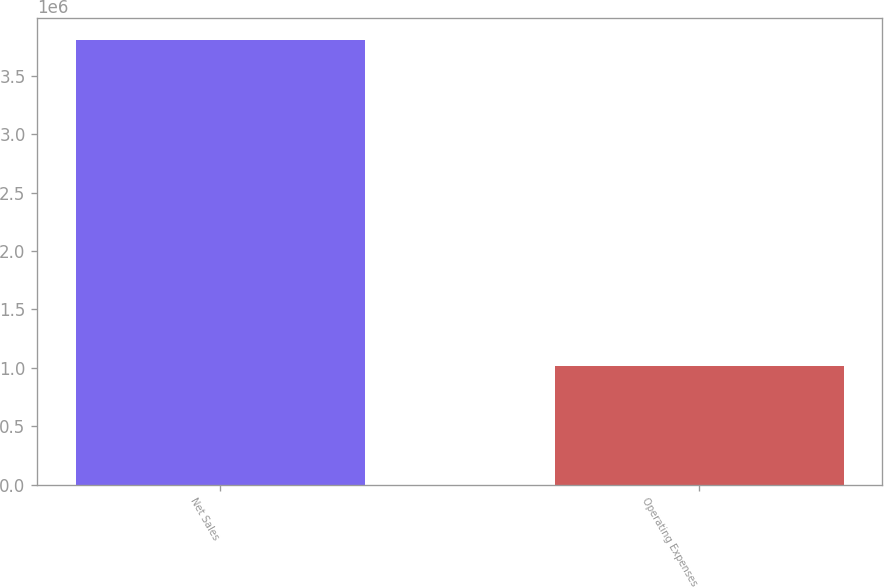<chart> <loc_0><loc_0><loc_500><loc_500><bar_chart><fcel>Net Sales<fcel>Operating Expenses<nl><fcel>3.80718e+06<fcel>1.01176e+06<nl></chart> 